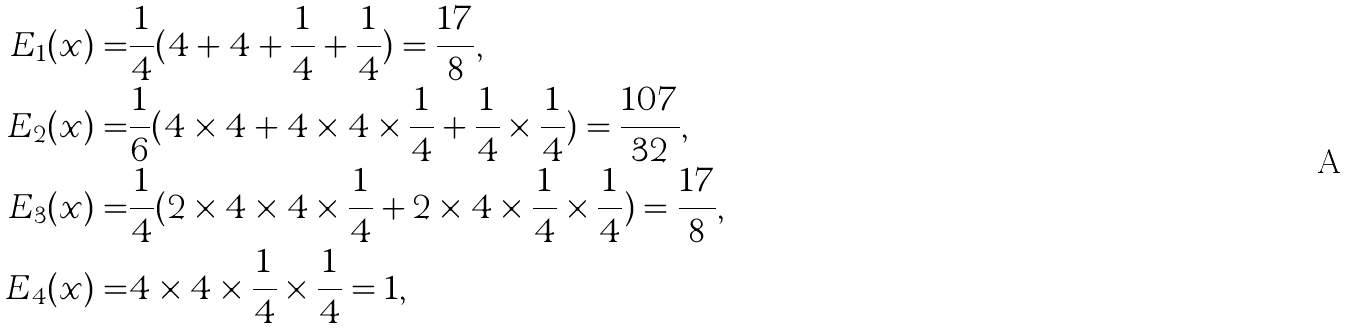<formula> <loc_0><loc_0><loc_500><loc_500>E _ { 1 } ( x ) = & \frac { 1 } { 4 } ( 4 + 4 + \frac { 1 } { 4 } + \frac { 1 } { 4 } ) = \frac { 1 7 } { 8 } , \\ E _ { 2 } ( x ) = & \frac { 1 } { 6 } ( 4 \times 4 + 4 \times 4 \times \frac { 1 } { 4 } + \frac { 1 } { 4 } \times \frac { 1 } { 4 } ) = \frac { 1 0 7 } { 3 2 } , \\ E _ { 3 } ( x ) = & \frac { 1 } { 4 } ( 2 \times 4 \times 4 \times \frac { 1 } { 4 } + 2 \times 4 \times \frac { 1 } { 4 } \times \frac { 1 } { 4 } ) = \frac { 1 7 } { 8 } , \\ E _ { 4 } ( x ) = & 4 \times 4 \times \frac { 1 } { 4 } \times \frac { 1 } { 4 } = 1 ,</formula> 